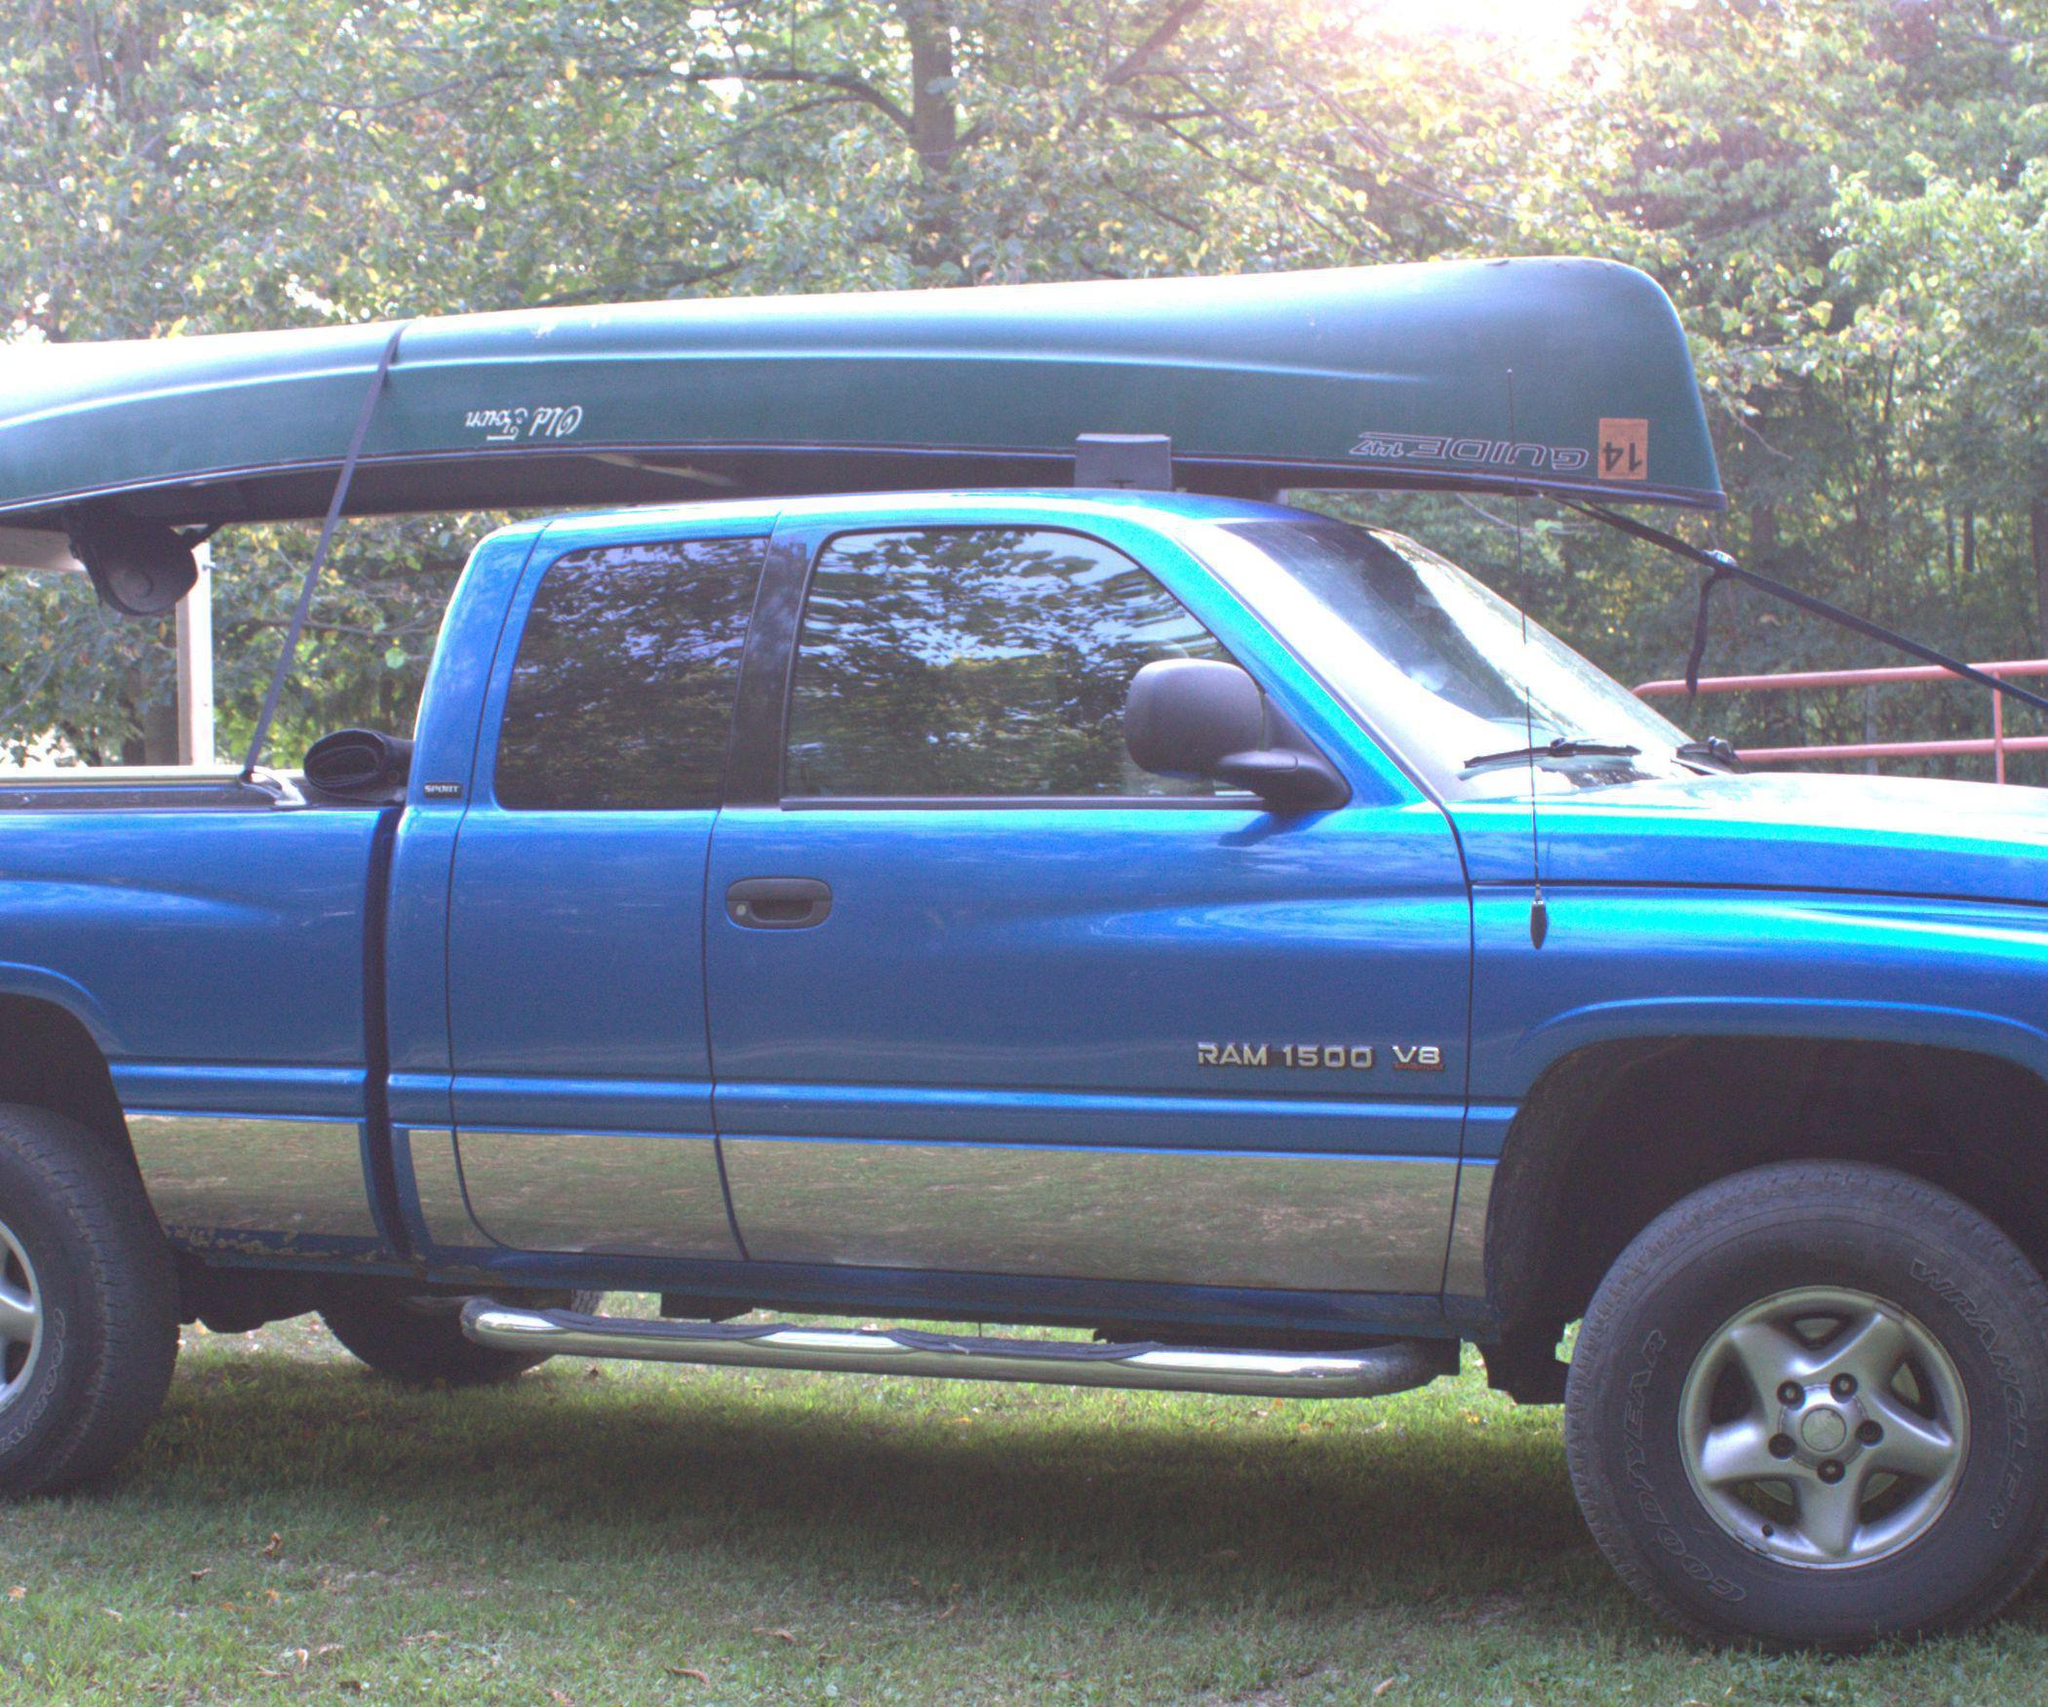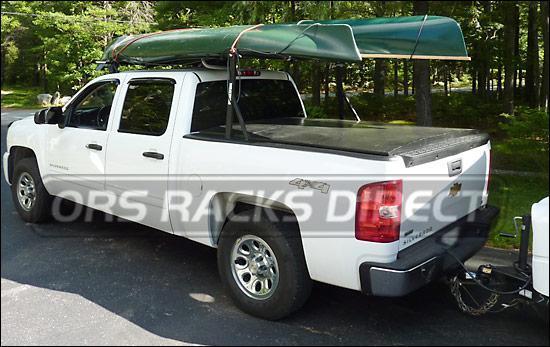The first image is the image on the left, the second image is the image on the right. Considering the images on both sides, is "In one image, a pickup truck has two different-colored boats loaded on an overhead rack." valid? Answer yes or no. No. 